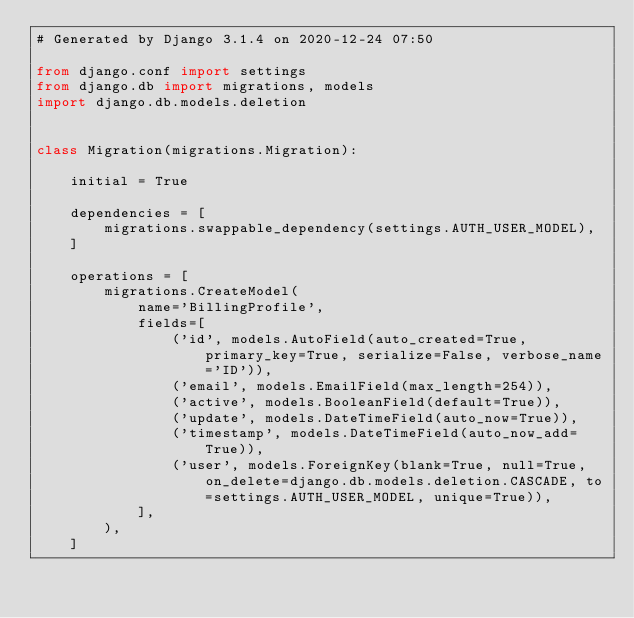<code> <loc_0><loc_0><loc_500><loc_500><_Python_># Generated by Django 3.1.4 on 2020-12-24 07:50

from django.conf import settings
from django.db import migrations, models
import django.db.models.deletion


class Migration(migrations.Migration):

    initial = True

    dependencies = [
        migrations.swappable_dependency(settings.AUTH_USER_MODEL),
    ]

    operations = [
        migrations.CreateModel(
            name='BillingProfile',
            fields=[
                ('id', models.AutoField(auto_created=True, primary_key=True, serialize=False, verbose_name='ID')),
                ('email', models.EmailField(max_length=254)),
                ('active', models.BooleanField(default=True)),
                ('update', models.DateTimeField(auto_now=True)),
                ('timestamp', models.DateTimeField(auto_now_add=True)),
                ('user', models.ForeignKey(blank=True, null=True, on_delete=django.db.models.deletion.CASCADE, to=settings.AUTH_USER_MODEL, unique=True)),
            ],
        ),
    ]
</code> 